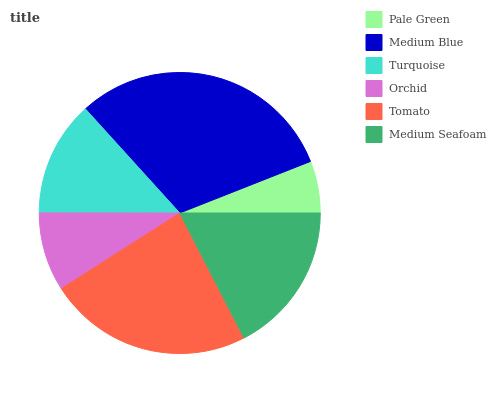Is Pale Green the minimum?
Answer yes or no. Yes. Is Medium Blue the maximum?
Answer yes or no. Yes. Is Turquoise the minimum?
Answer yes or no. No. Is Turquoise the maximum?
Answer yes or no. No. Is Medium Blue greater than Turquoise?
Answer yes or no. Yes. Is Turquoise less than Medium Blue?
Answer yes or no. Yes. Is Turquoise greater than Medium Blue?
Answer yes or no. No. Is Medium Blue less than Turquoise?
Answer yes or no. No. Is Medium Seafoam the high median?
Answer yes or no. Yes. Is Turquoise the low median?
Answer yes or no. Yes. Is Turquoise the high median?
Answer yes or no. No. Is Pale Green the low median?
Answer yes or no. No. 